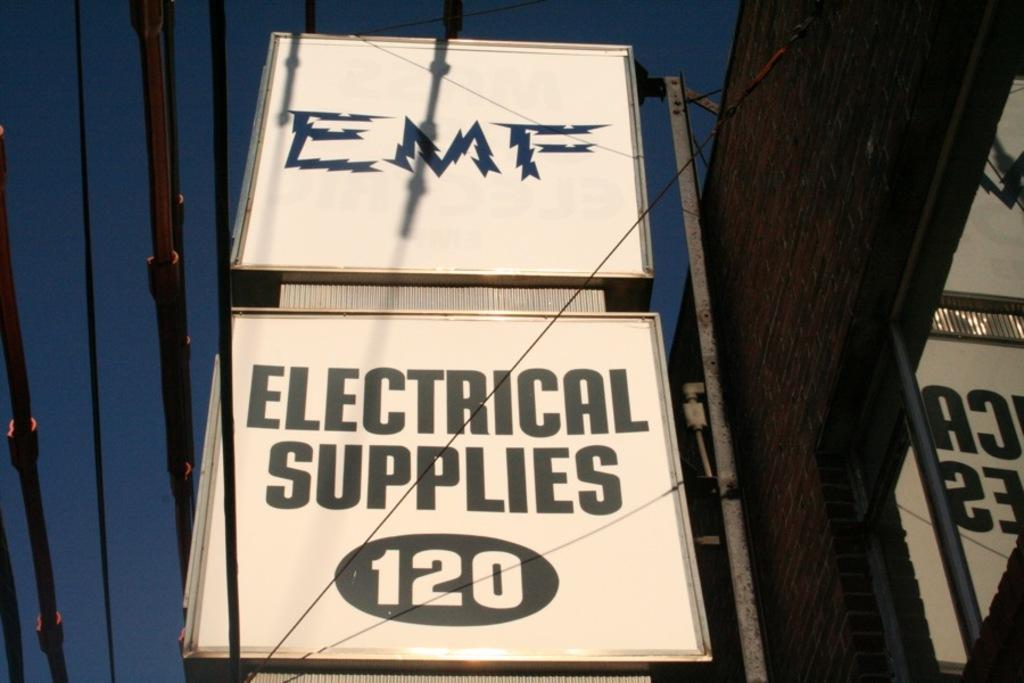<image>
Summarize the visual content of the image. electrical supplies has a large white square sign 